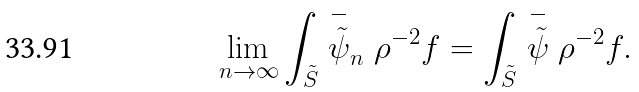<formula> <loc_0><loc_0><loc_500><loc_500>\lim _ { n \to \infty } \int _ { \tilde { S } } \stackrel { - } { \tilde { \psi } } _ { n } \rho ^ { - 2 } f = \int _ { \tilde { S } } \stackrel { - } { \tilde { \psi } } \rho ^ { - 2 } f .</formula> 